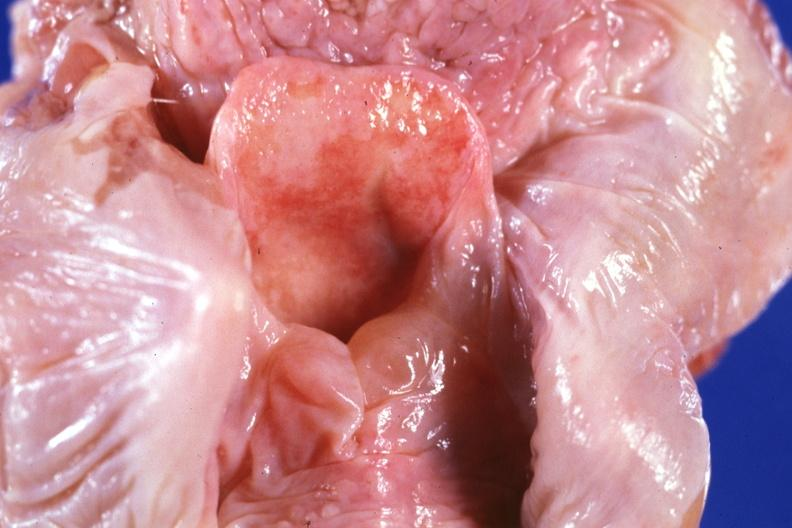what is present?
Answer the question using a single word or phrase. Larynx 